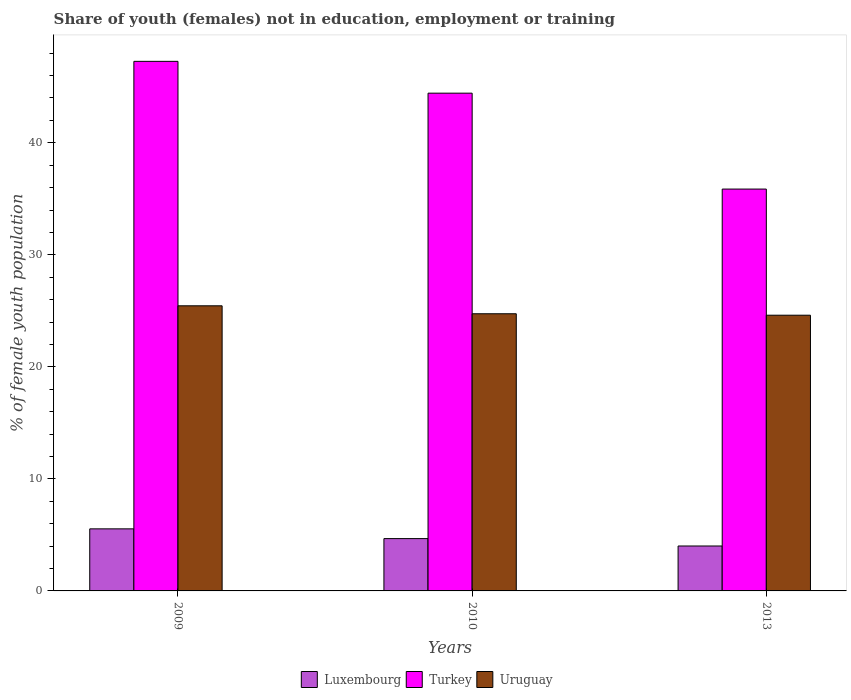How many different coloured bars are there?
Ensure brevity in your answer.  3. Are the number of bars per tick equal to the number of legend labels?
Ensure brevity in your answer.  Yes. How many bars are there on the 1st tick from the right?
Offer a terse response. 3. What is the percentage of unemployed female population in in Uruguay in 2010?
Provide a short and direct response. 24.74. Across all years, what is the maximum percentage of unemployed female population in in Uruguay?
Give a very brief answer. 25.45. Across all years, what is the minimum percentage of unemployed female population in in Luxembourg?
Your response must be concise. 4.01. What is the total percentage of unemployed female population in in Turkey in the graph?
Your answer should be very brief. 127.57. What is the difference between the percentage of unemployed female population in in Uruguay in 2009 and that in 2010?
Provide a succinct answer. 0.71. What is the difference between the percentage of unemployed female population in in Turkey in 2009 and the percentage of unemployed female population in in Uruguay in 2013?
Ensure brevity in your answer.  22.66. What is the average percentage of unemployed female population in in Turkey per year?
Keep it short and to the point. 42.52. In the year 2010, what is the difference between the percentage of unemployed female population in in Uruguay and percentage of unemployed female population in in Turkey?
Make the answer very short. -19.69. In how many years, is the percentage of unemployed female population in in Luxembourg greater than 16 %?
Ensure brevity in your answer.  0. What is the ratio of the percentage of unemployed female population in in Turkey in 2009 to that in 2013?
Your answer should be compact. 1.32. Is the difference between the percentage of unemployed female population in in Uruguay in 2009 and 2013 greater than the difference between the percentage of unemployed female population in in Turkey in 2009 and 2013?
Provide a succinct answer. No. What is the difference between the highest and the second highest percentage of unemployed female population in in Luxembourg?
Your response must be concise. 0.87. What is the difference between the highest and the lowest percentage of unemployed female population in in Luxembourg?
Provide a succinct answer. 1.53. In how many years, is the percentage of unemployed female population in in Uruguay greater than the average percentage of unemployed female population in in Uruguay taken over all years?
Your response must be concise. 1. What does the 1st bar from the right in 2009 represents?
Offer a very short reply. Uruguay. Is it the case that in every year, the sum of the percentage of unemployed female population in in Turkey and percentage of unemployed female population in in Luxembourg is greater than the percentage of unemployed female population in in Uruguay?
Your answer should be very brief. Yes. Does the graph contain any zero values?
Your answer should be compact. No. Does the graph contain grids?
Your answer should be compact. No. Where does the legend appear in the graph?
Your answer should be very brief. Bottom center. How are the legend labels stacked?
Your answer should be compact. Horizontal. What is the title of the graph?
Your answer should be compact. Share of youth (females) not in education, employment or training. Does "Low income" appear as one of the legend labels in the graph?
Give a very brief answer. No. What is the label or title of the X-axis?
Provide a succinct answer. Years. What is the label or title of the Y-axis?
Provide a short and direct response. % of female youth population. What is the % of female youth population of Luxembourg in 2009?
Your answer should be very brief. 5.54. What is the % of female youth population in Turkey in 2009?
Keep it short and to the point. 47.27. What is the % of female youth population in Uruguay in 2009?
Provide a succinct answer. 25.45. What is the % of female youth population of Luxembourg in 2010?
Offer a very short reply. 4.67. What is the % of female youth population in Turkey in 2010?
Offer a terse response. 44.43. What is the % of female youth population of Uruguay in 2010?
Give a very brief answer. 24.74. What is the % of female youth population in Luxembourg in 2013?
Provide a succinct answer. 4.01. What is the % of female youth population of Turkey in 2013?
Your answer should be compact. 35.87. What is the % of female youth population in Uruguay in 2013?
Give a very brief answer. 24.61. Across all years, what is the maximum % of female youth population of Luxembourg?
Your response must be concise. 5.54. Across all years, what is the maximum % of female youth population in Turkey?
Offer a very short reply. 47.27. Across all years, what is the maximum % of female youth population in Uruguay?
Offer a very short reply. 25.45. Across all years, what is the minimum % of female youth population in Luxembourg?
Make the answer very short. 4.01. Across all years, what is the minimum % of female youth population in Turkey?
Offer a very short reply. 35.87. Across all years, what is the minimum % of female youth population of Uruguay?
Provide a short and direct response. 24.61. What is the total % of female youth population in Luxembourg in the graph?
Your answer should be very brief. 14.22. What is the total % of female youth population in Turkey in the graph?
Give a very brief answer. 127.57. What is the total % of female youth population in Uruguay in the graph?
Offer a very short reply. 74.8. What is the difference between the % of female youth population of Luxembourg in 2009 and that in 2010?
Your answer should be very brief. 0.87. What is the difference between the % of female youth population of Turkey in 2009 and that in 2010?
Make the answer very short. 2.84. What is the difference between the % of female youth population of Uruguay in 2009 and that in 2010?
Make the answer very short. 0.71. What is the difference between the % of female youth population in Luxembourg in 2009 and that in 2013?
Provide a succinct answer. 1.53. What is the difference between the % of female youth population of Turkey in 2009 and that in 2013?
Provide a succinct answer. 11.4. What is the difference between the % of female youth population in Uruguay in 2009 and that in 2013?
Your response must be concise. 0.84. What is the difference between the % of female youth population of Luxembourg in 2010 and that in 2013?
Provide a short and direct response. 0.66. What is the difference between the % of female youth population in Turkey in 2010 and that in 2013?
Your answer should be very brief. 8.56. What is the difference between the % of female youth population in Uruguay in 2010 and that in 2013?
Provide a short and direct response. 0.13. What is the difference between the % of female youth population in Luxembourg in 2009 and the % of female youth population in Turkey in 2010?
Ensure brevity in your answer.  -38.89. What is the difference between the % of female youth population of Luxembourg in 2009 and the % of female youth population of Uruguay in 2010?
Offer a very short reply. -19.2. What is the difference between the % of female youth population of Turkey in 2009 and the % of female youth population of Uruguay in 2010?
Your answer should be compact. 22.53. What is the difference between the % of female youth population in Luxembourg in 2009 and the % of female youth population in Turkey in 2013?
Make the answer very short. -30.33. What is the difference between the % of female youth population of Luxembourg in 2009 and the % of female youth population of Uruguay in 2013?
Your answer should be very brief. -19.07. What is the difference between the % of female youth population of Turkey in 2009 and the % of female youth population of Uruguay in 2013?
Your response must be concise. 22.66. What is the difference between the % of female youth population in Luxembourg in 2010 and the % of female youth population in Turkey in 2013?
Your answer should be very brief. -31.2. What is the difference between the % of female youth population in Luxembourg in 2010 and the % of female youth population in Uruguay in 2013?
Provide a succinct answer. -19.94. What is the difference between the % of female youth population in Turkey in 2010 and the % of female youth population in Uruguay in 2013?
Your response must be concise. 19.82. What is the average % of female youth population of Luxembourg per year?
Make the answer very short. 4.74. What is the average % of female youth population of Turkey per year?
Provide a short and direct response. 42.52. What is the average % of female youth population of Uruguay per year?
Keep it short and to the point. 24.93. In the year 2009, what is the difference between the % of female youth population in Luxembourg and % of female youth population in Turkey?
Ensure brevity in your answer.  -41.73. In the year 2009, what is the difference between the % of female youth population of Luxembourg and % of female youth population of Uruguay?
Keep it short and to the point. -19.91. In the year 2009, what is the difference between the % of female youth population of Turkey and % of female youth population of Uruguay?
Make the answer very short. 21.82. In the year 2010, what is the difference between the % of female youth population in Luxembourg and % of female youth population in Turkey?
Offer a very short reply. -39.76. In the year 2010, what is the difference between the % of female youth population of Luxembourg and % of female youth population of Uruguay?
Give a very brief answer. -20.07. In the year 2010, what is the difference between the % of female youth population in Turkey and % of female youth population in Uruguay?
Your answer should be compact. 19.69. In the year 2013, what is the difference between the % of female youth population of Luxembourg and % of female youth population of Turkey?
Make the answer very short. -31.86. In the year 2013, what is the difference between the % of female youth population of Luxembourg and % of female youth population of Uruguay?
Give a very brief answer. -20.6. In the year 2013, what is the difference between the % of female youth population of Turkey and % of female youth population of Uruguay?
Give a very brief answer. 11.26. What is the ratio of the % of female youth population in Luxembourg in 2009 to that in 2010?
Your answer should be very brief. 1.19. What is the ratio of the % of female youth population of Turkey in 2009 to that in 2010?
Provide a short and direct response. 1.06. What is the ratio of the % of female youth population in Uruguay in 2009 to that in 2010?
Make the answer very short. 1.03. What is the ratio of the % of female youth population of Luxembourg in 2009 to that in 2013?
Ensure brevity in your answer.  1.38. What is the ratio of the % of female youth population of Turkey in 2009 to that in 2013?
Provide a succinct answer. 1.32. What is the ratio of the % of female youth population in Uruguay in 2009 to that in 2013?
Provide a short and direct response. 1.03. What is the ratio of the % of female youth population in Luxembourg in 2010 to that in 2013?
Your answer should be very brief. 1.16. What is the ratio of the % of female youth population of Turkey in 2010 to that in 2013?
Keep it short and to the point. 1.24. What is the difference between the highest and the second highest % of female youth population of Luxembourg?
Ensure brevity in your answer.  0.87. What is the difference between the highest and the second highest % of female youth population in Turkey?
Provide a succinct answer. 2.84. What is the difference between the highest and the second highest % of female youth population of Uruguay?
Provide a succinct answer. 0.71. What is the difference between the highest and the lowest % of female youth population in Luxembourg?
Give a very brief answer. 1.53. What is the difference between the highest and the lowest % of female youth population in Turkey?
Your answer should be very brief. 11.4. What is the difference between the highest and the lowest % of female youth population of Uruguay?
Your answer should be compact. 0.84. 